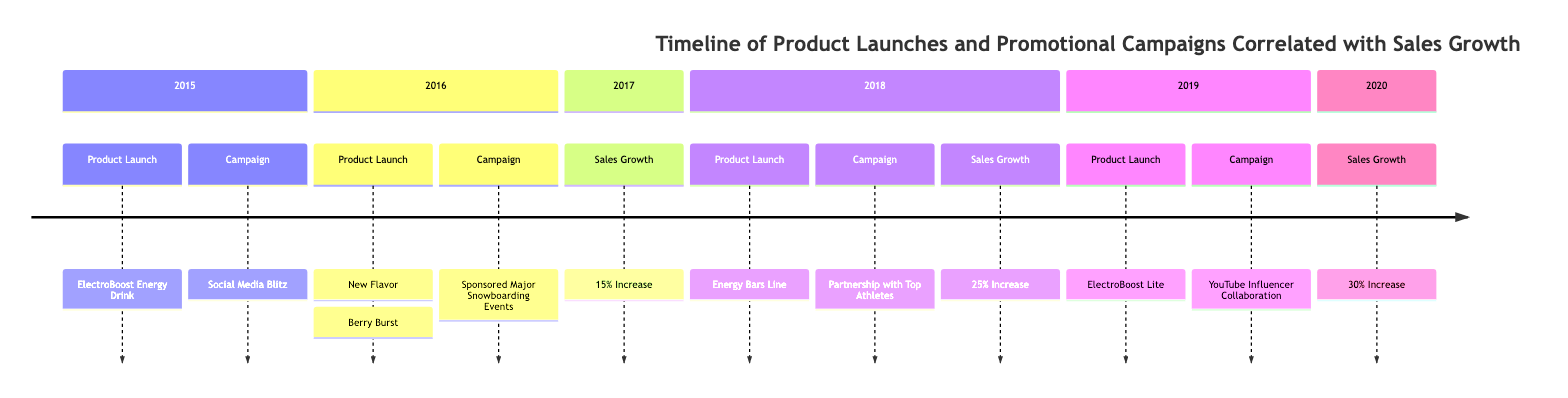What product was launched in 2015? The diagram indicates that the product launched in 2015 is "ElectroBoost Energy Drink." This is found in the 2015 section under Product Launch.
Answer: ElectroBoost Energy Drink What campaign was associated with the 2016 product launch? In the diagram, the campaign associated with the 2016 product launch of "New Flavor: Berry Burst" is "Sponsored Major Snowboarding Events." This is also found in the 2016 section.
Answer: Sponsored Major Snowboarding Events What was the percentage increase in sales in 2018? According to the diagram, the sales growth in 2018 was noted as a "25% Increase." This information appears under the Sales Growth section in 2018.
Answer: 25% Increase Which year had the highest sales growth rate? By analyzing the sales growth data presented in the diagram, the year 2020 had a "30% Increase," which is the highest when compared to the other years.
Answer: 30% Increase What product was launched after the Energy Bars Line? The timeline specifies that after the "Energy Bars Line" launched in 2018, the next product launched was "ElectroBoost Lite" in 2019. This is found in the subsequent section following 2018.
Answer: ElectroBoost Lite How many distinct promotional campaigns are mentioned in the diagram? The diagram includes several promotional campaigns: "Social Media Blitz," "Sponsored Major Snowboarding Events," "Partnership with Top Athletes," and "YouTube Influencer Collaboration." Counting these gives a total of 4 distinct campaigns.
Answer: 4 What correlation can be observed between product launches and sales growth? Reviewing the timeline, it can be seen that each product launch corresponds with an increase in sales, as there are notable sales growth percentages listed for 2017, 2018, and 2020 following specific product launches. Therefore, the correlation is a general trend of increasing sales with new product introductions.
Answer: Positive correlation In which year did the Energy Bars Line launch? The diagram notes that the "Energy Bars Line" was launched in 2018. This event is explicitly stated under the 2018 section of the timeline.
Answer: 2018 